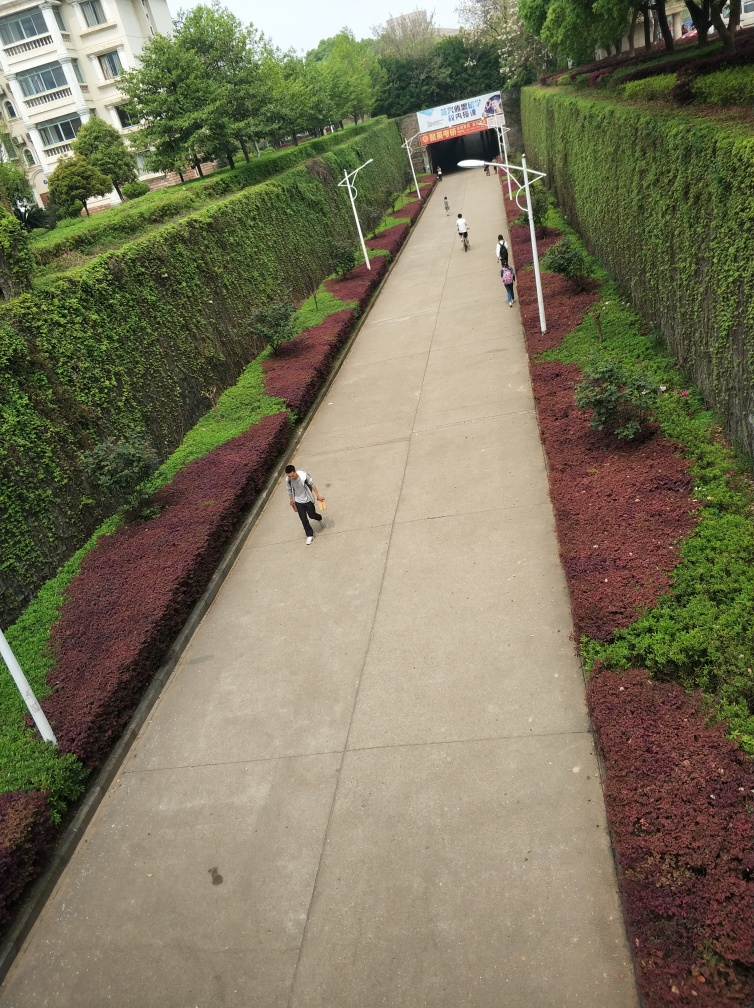What is the likely purpose of the tunnel at the end of the pathway? The tunnel at the end of the pathway looks like a pedestrian underpass. It likely serves as a safe crossing point beneath a road or another form of barrier, enabling pedestrians to bypass traffic or physical obstacles. The signage above the tunnel might indicate directions, rules, or provide information about the tunnel's destination. Such infrastructure is common in urban planning to facilitate foot traffic and enhance safety for walkers and cyclists. 